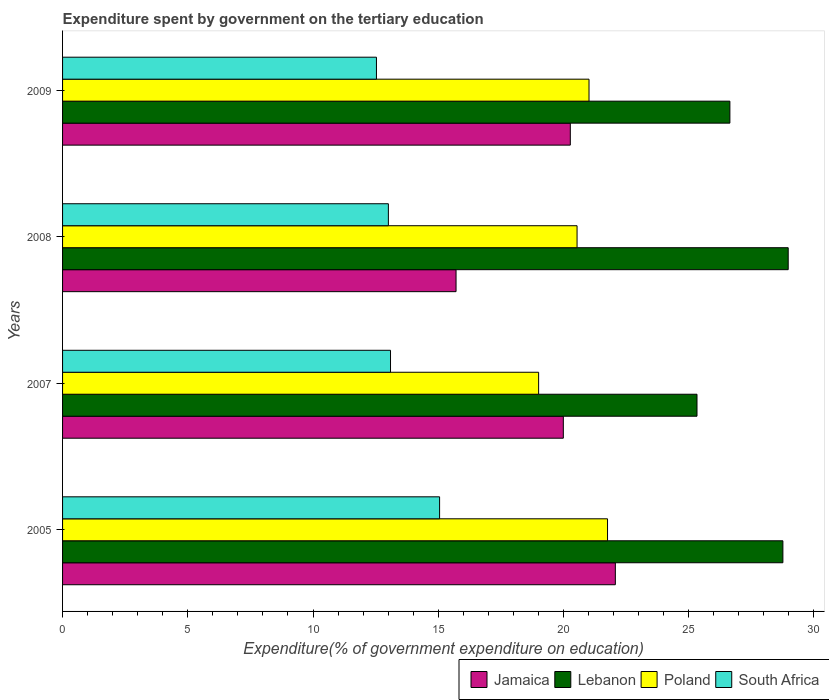Are the number of bars per tick equal to the number of legend labels?
Provide a succinct answer. Yes. Are the number of bars on each tick of the Y-axis equal?
Make the answer very short. Yes. How many bars are there on the 4th tick from the top?
Keep it short and to the point. 4. How many bars are there on the 1st tick from the bottom?
Your response must be concise. 4. In how many cases, is the number of bars for a given year not equal to the number of legend labels?
Your answer should be compact. 0. What is the expenditure spent by government on the tertiary education in Jamaica in 2005?
Provide a short and direct response. 22.07. Across all years, what is the maximum expenditure spent by government on the tertiary education in Lebanon?
Offer a terse response. 28.98. Across all years, what is the minimum expenditure spent by government on the tertiary education in Jamaica?
Keep it short and to the point. 15.71. In which year was the expenditure spent by government on the tertiary education in Poland minimum?
Your answer should be compact. 2007. What is the total expenditure spent by government on the tertiary education in Poland in the graph?
Offer a terse response. 82.33. What is the difference between the expenditure spent by government on the tertiary education in Lebanon in 2005 and that in 2009?
Make the answer very short. 2.12. What is the difference between the expenditure spent by government on the tertiary education in Lebanon in 2008 and the expenditure spent by government on the tertiary education in Jamaica in 2007?
Give a very brief answer. 8.98. What is the average expenditure spent by government on the tertiary education in Lebanon per year?
Your answer should be very brief. 27.43. In the year 2007, what is the difference between the expenditure spent by government on the tertiary education in Jamaica and expenditure spent by government on the tertiary education in South Africa?
Offer a terse response. 6.9. In how many years, is the expenditure spent by government on the tertiary education in Lebanon greater than 15 %?
Give a very brief answer. 4. What is the ratio of the expenditure spent by government on the tertiary education in South Africa in 2005 to that in 2008?
Provide a succinct answer. 1.16. Is the expenditure spent by government on the tertiary education in Jamaica in 2007 less than that in 2009?
Make the answer very short. Yes. What is the difference between the highest and the second highest expenditure spent by government on the tertiary education in South Africa?
Your answer should be very brief. 1.96. What is the difference between the highest and the lowest expenditure spent by government on the tertiary education in Poland?
Offer a terse response. 2.75. Is it the case that in every year, the sum of the expenditure spent by government on the tertiary education in South Africa and expenditure spent by government on the tertiary education in Jamaica is greater than the sum of expenditure spent by government on the tertiary education in Lebanon and expenditure spent by government on the tertiary education in Poland?
Provide a succinct answer. Yes. What does the 2nd bar from the top in 2008 represents?
Provide a succinct answer. Poland. Are all the bars in the graph horizontal?
Ensure brevity in your answer.  Yes. What is the difference between two consecutive major ticks on the X-axis?
Your answer should be very brief. 5. Does the graph contain any zero values?
Your answer should be very brief. No. Does the graph contain grids?
Your answer should be very brief. No. Where does the legend appear in the graph?
Your answer should be very brief. Bottom right. How many legend labels are there?
Ensure brevity in your answer.  4. What is the title of the graph?
Provide a succinct answer. Expenditure spent by government on the tertiary education. Does "Latin America(all income levels)" appear as one of the legend labels in the graph?
Give a very brief answer. No. What is the label or title of the X-axis?
Ensure brevity in your answer.  Expenditure(% of government expenditure on education). What is the label or title of the Y-axis?
Offer a terse response. Years. What is the Expenditure(% of government expenditure on education) in Jamaica in 2005?
Ensure brevity in your answer.  22.07. What is the Expenditure(% of government expenditure on education) in Lebanon in 2005?
Provide a succinct answer. 28.76. What is the Expenditure(% of government expenditure on education) in Poland in 2005?
Your answer should be very brief. 21.76. What is the Expenditure(% of government expenditure on education) of South Africa in 2005?
Make the answer very short. 15.05. What is the Expenditure(% of government expenditure on education) in Jamaica in 2007?
Ensure brevity in your answer.  20. What is the Expenditure(% of government expenditure on education) in Lebanon in 2007?
Ensure brevity in your answer.  25.33. What is the Expenditure(% of government expenditure on education) in Poland in 2007?
Provide a short and direct response. 19.01. What is the Expenditure(% of government expenditure on education) of South Africa in 2007?
Give a very brief answer. 13.1. What is the Expenditure(% of government expenditure on education) in Jamaica in 2008?
Your response must be concise. 15.71. What is the Expenditure(% of government expenditure on education) of Lebanon in 2008?
Offer a very short reply. 28.98. What is the Expenditure(% of government expenditure on education) of Poland in 2008?
Your response must be concise. 20.54. What is the Expenditure(% of government expenditure on education) in South Africa in 2008?
Offer a very short reply. 13.01. What is the Expenditure(% of government expenditure on education) in Jamaica in 2009?
Offer a terse response. 20.27. What is the Expenditure(% of government expenditure on education) of Lebanon in 2009?
Provide a short and direct response. 26.65. What is the Expenditure(% of government expenditure on education) of Poland in 2009?
Make the answer very short. 21.02. What is the Expenditure(% of government expenditure on education) of South Africa in 2009?
Your answer should be compact. 12.53. Across all years, what is the maximum Expenditure(% of government expenditure on education) of Jamaica?
Give a very brief answer. 22.07. Across all years, what is the maximum Expenditure(% of government expenditure on education) in Lebanon?
Offer a terse response. 28.98. Across all years, what is the maximum Expenditure(% of government expenditure on education) of Poland?
Keep it short and to the point. 21.76. Across all years, what is the maximum Expenditure(% of government expenditure on education) in South Africa?
Provide a succinct answer. 15.05. Across all years, what is the minimum Expenditure(% of government expenditure on education) of Jamaica?
Make the answer very short. 15.71. Across all years, what is the minimum Expenditure(% of government expenditure on education) of Lebanon?
Give a very brief answer. 25.33. Across all years, what is the minimum Expenditure(% of government expenditure on education) of Poland?
Give a very brief answer. 19.01. Across all years, what is the minimum Expenditure(% of government expenditure on education) of South Africa?
Ensure brevity in your answer.  12.53. What is the total Expenditure(% of government expenditure on education) of Jamaica in the graph?
Keep it short and to the point. 78.05. What is the total Expenditure(% of government expenditure on education) in Lebanon in the graph?
Make the answer very short. 109.72. What is the total Expenditure(% of government expenditure on education) in Poland in the graph?
Give a very brief answer. 82.33. What is the total Expenditure(% of government expenditure on education) in South Africa in the graph?
Make the answer very short. 53.69. What is the difference between the Expenditure(% of government expenditure on education) of Jamaica in 2005 and that in 2007?
Your response must be concise. 2.08. What is the difference between the Expenditure(% of government expenditure on education) in Lebanon in 2005 and that in 2007?
Offer a very short reply. 3.43. What is the difference between the Expenditure(% of government expenditure on education) of Poland in 2005 and that in 2007?
Keep it short and to the point. 2.75. What is the difference between the Expenditure(% of government expenditure on education) of South Africa in 2005 and that in 2007?
Keep it short and to the point. 1.96. What is the difference between the Expenditure(% of government expenditure on education) in Jamaica in 2005 and that in 2008?
Your answer should be very brief. 6.36. What is the difference between the Expenditure(% of government expenditure on education) in Lebanon in 2005 and that in 2008?
Your answer should be compact. -0.21. What is the difference between the Expenditure(% of government expenditure on education) in Poland in 2005 and that in 2008?
Provide a short and direct response. 1.22. What is the difference between the Expenditure(% of government expenditure on education) in South Africa in 2005 and that in 2008?
Your answer should be compact. 2.05. What is the difference between the Expenditure(% of government expenditure on education) in Jamaica in 2005 and that in 2009?
Provide a short and direct response. 1.8. What is the difference between the Expenditure(% of government expenditure on education) in Lebanon in 2005 and that in 2009?
Keep it short and to the point. 2.12. What is the difference between the Expenditure(% of government expenditure on education) in Poland in 2005 and that in 2009?
Give a very brief answer. 0.74. What is the difference between the Expenditure(% of government expenditure on education) in South Africa in 2005 and that in 2009?
Your answer should be very brief. 2.52. What is the difference between the Expenditure(% of government expenditure on education) in Jamaica in 2007 and that in 2008?
Provide a succinct answer. 4.28. What is the difference between the Expenditure(% of government expenditure on education) of Lebanon in 2007 and that in 2008?
Ensure brevity in your answer.  -3.64. What is the difference between the Expenditure(% of government expenditure on education) of Poland in 2007 and that in 2008?
Your answer should be compact. -1.54. What is the difference between the Expenditure(% of government expenditure on education) of South Africa in 2007 and that in 2008?
Offer a very short reply. 0.09. What is the difference between the Expenditure(% of government expenditure on education) in Jamaica in 2007 and that in 2009?
Offer a very short reply. -0.28. What is the difference between the Expenditure(% of government expenditure on education) of Lebanon in 2007 and that in 2009?
Provide a short and direct response. -1.31. What is the difference between the Expenditure(% of government expenditure on education) of Poland in 2007 and that in 2009?
Provide a short and direct response. -2.01. What is the difference between the Expenditure(% of government expenditure on education) in South Africa in 2007 and that in 2009?
Your answer should be compact. 0.56. What is the difference between the Expenditure(% of government expenditure on education) in Jamaica in 2008 and that in 2009?
Make the answer very short. -4.56. What is the difference between the Expenditure(% of government expenditure on education) in Lebanon in 2008 and that in 2009?
Your response must be concise. 2.33. What is the difference between the Expenditure(% of government expenditure on education) of Poland in 2008 and that in 2009?
Make the answer very short. -0.48. What is the difference between the Expenditure(% of government expenditure on education) of South Africa in 2008 and that in 2009?
Provide a succinct answer. 0.48. What is the difference between the Expenditure(% of government expenditure on education) in Jamaica in 2005 and the Expenditure(% of government expenditure on education) in Lebanon in 2007?
Provide a succinct answer. -3.26. What is the difference between the Expenditure(% of government expenditure on education) of Jamaica in 2005 and the Expenditure(% of government expenditure on education) of Poland in 2007?
Keep it short and to the point. 3.06. What is the difference between the Expenditure(% of government expenditure on education) of Jamaica in 2005 and the Expenditure(% of government expenditure on education) of South Africa in 2007?
Give a very brief answer. 8.98. What is the difference between the Expenditure(% of government expenditure on education) of Lebanon in 2005 and the Expenditure(% of government expenditure on education) of Poland in 2007?
Offer a terse response. 9.75. What is the difference between the Expenditure(% of government expenditure on education) of Lebanon in 2005 and the Expenditure(% of government expenditure on education) of South Africa in 2007?
Your response must be concise. 15.67. What is the difference between the Expenditure(% of government expenditure on education) of Poland in 2005 and the Expenditure(% of government expenditure on education) of South Africa in 2007?
Provide a short and direct response. 8.67. What is the difference between the Expenditure(% of government expenditure on education) of Jamaica in 2005 and the Expenditure(% of government expenditure on education) of Lebanon in 2008?
Your answer should be very brief. -6.9. What is the difference between the Expenditure(% of government expenditure on education) in Jamaica in 2005 and the Expenditure(% of government expenditure on education) in Poland in 2008?
Offer a terse response. 1.53. What is the difference between the Expenditure(% of government expenditure on education) of Jamaica in 2005 and the Expenditure(% of government expenditure on education) of South Africa in 2008?
Offer a very short reply. 9.06. What is the difference between the Expenditure(% of government expenditure on education) of Lebanon in 2005 and the Expenditure(% of government expenditure on education) of Poland in 2008?
Provide a short and direct response. 8.22. What is the difference between the Expenditure(% of government expenditure on education) in Lebanon in 2005 and the Expenditure(% of government expenditure on education) in South Africa in 2008?
Keep it short and to the point. 15.75. What is the difference between the Expenditure(% of government expenditure on education) in Poland in 2005 and the Expenditure(% of government expenditure on education) in South Africa in 2008?
Give a very brief answer. 8.75. What is the difference between the Expenditure(% of government expenditure on education) in Jamaica in 2005 and the Expenditure(% of government expenditure on education) in Lebanon in 2009?
Give a very brief answer. -4.57. What is the difference between the Expenditure(% of government expenditure on education) of Jamaica in 2005 and the Expenditure(% of government expenditure on education) of Poland in 2009?
Provide a succinct answer. 1.05. What is the difference between the Expenditure(% of government expenditure on education) in Jamaica in 2005 and the Expenditure(% of government expenditure on education) in South Africa in 2009?
Your response must be concise. 9.54. What is the difference between the Expenditure(% of government expenditure on education) of Lebanon in 2005 and the Expenditure(% of government expenditure on education) of Poland in 2009?
Give a very brief answer. 7.74. What is the difference between the Expenditure(% of government expenditure on education) of Lebanon in 2005 and the Expenditure(% of government expenditure on education) of South Africa in 2009?
Your answer should be compact. 16.23. What is the difference between the Expenditure(% of government expenditure on education) of Poland in 2005 and the Expenditure(% of government expenditure on education) of South Africa in 2009?
Give a very brief answer. 9.23. What is the difference between the Expenditure(% of government expenditure on education) of Jamaica in 2007 and the Expenditure(% of government expenditure on education) of Lebanon in 2008?
Provide a short and direct response. -8.98. What is the difference between the Expenditure(% of government expenditure on education) in Jamaica in 2007 and the Expenditure(% of government expenditure on education) in Poland in 2008?
Your answer should be very brief. -0.55. What is the difference between the Expenditure(% of government expenditure on education) in Jamaica in 2007 and the Expenditure(% of government expenditure on education) in South Africa in 2008?
Provide a short and direct response. 6.99. What is the difference between the Expenditure(% of government expenditure on education) in Lebanon in 2007 and the Expenditure(% of government expenditure on education) in Poland in 2008?
Keep it short and to the point. 4.79. What is the difference between the Expenditure(% of government expenditure on education) of Lebanon in 2007 and the Expenditure(% of government expenditure on education) of South Africa in 2008?
Make the answer very short. 12.32. What is the difference between the Expenditure(% of government expenditure on education) in Poland in 2007 and the Expenditure(% of government expenditure on education) in South Africa in 2008?
Offer a very short reply. 6. What is the difference between the Expenditure(% of government expenditure on education) in Jamaica in 2007 and the Expenditure(% of government expenditure on education) in Lebanon in 2009?
Ensure brevity in your answer.  -6.65. What is the difference between the Expenditure(% of government expenditure on education) in Jamaica in 2007 and the Expenditure(% of government expenditure on education) in Poland in 2009?
Offer a very short reply. -1.03. What is the difference between the Expenditure(% of government expenditure on education) in Jamaica in 2007 and the Expenditure(% of government expenditure on education) in South Africa in 2009?
Make the answer very short. 7.46. What is the difference between the Expenditure(% of government expenditure on education) of Lebanon in 2007 and the Expenditure(% of government expenditure on education) of Poland in 2009?
Offer a very short reply. 4.31. What is the difference between the Expenditure(% of government expenditure on education) in Lebanon in 2007 and the Expenditure(% of government expenditure on education) in South Africa in 2009?
Your answer should be very brief. 12.8. What is the difference between the Expenditure(% of government expenditure on education) of Poland in 2007 and the Expenditure(% of government expenditure on education) of South Africa in 2009?
Provide a short and direct response. 6.48. What is the difference between the Expenditure(% of government expenditure on education) in Jamaica in 2008 and the Expenditure(% of government expenditure on education) in Lebanon in 2009?
Your answer should be very brief. -10.93. What is the difference between the Expenditure(% of government expenditure on education) in Jamaica in 2008 and the Expenditure(% of government expenditure on education) in Poland in 2009?
Your answer should be compact. -5.31. What is the difference between the Expenditure(% of government expenditure on education) in Jamaica in 2008 and the Expenditure(% of government expenditure on education) in South Africa in 2009?
Make the answer very short. 3.18. What is the difference between the Expenditure(% of government expenditure on education) in Lebanon in 2008 and the Expenditure(% of government expenditure on education) in Poland in 2009?
Offer a very short reply. 7.95. What is the difference between the Expenditure(% of government expenditure on education) in Lebanon in 2008 and the Expenditure(% of government expenditure on education) in South Africa in 2009?
Make the answer very short. 16.44. What is the difference between the Expenditure(% of government expenditure on education) of Poland in 2008 and the Expenditure(% of government expenditure on education) of South Africa in 2009?
Provide a short and direct response. 8.01. What is the average Expenditure(% of government expenditure on education) in Jamaica per year?
Provide a short and direct response. 19.51. What is the average Expenditure(% of government expenditure on education) of Lebanon per year?
Provide a succinct answer. 27.43. What is the average Expenditure(% of government expenditure on education) of Poland per year?
Ensure brevity in your answer.  20.58. What is the average Expenditure(% of government expenditure on education) of South Africa per year?
Provide a succinct answer. 13.42. In the year 2005, what is the difference between the Expenditure(% of government expenditure on education) of Jamaica and Expenditure(% of government expenditure on education) of Lebanon?
Provide a succinct answer. -6.69. In the year 2005, what is the difference between the Expenditure(% of government expenditure on education) in Jamaica and Expenditure(% of government expenditure on education) in Poland?
Give a very brief answer. 0.31. In the year 2005, what is the difference between the Expenditure(% of government expenditure on education) in Jamaica and Expenditure(% of government expenditure on education) in South Africa?
Your response must be concise. 7.02. In the year 2005, what is the difference between the Expenditure(% of government expenditure on education) of Lebanon and Expenditure(% of government expenditure on education) of Poland?
Ensure brevity in your answer.  7. In the year 2005, what is the difference between the Expenditure(% of government expenditure on education) of Lebanon and Expenditure(% of government expenditure on education) of South Africa?
Keep it short and to the point. 13.71. In the year 2005, what is the difference between the Expenditure(% of government expenditure on education) of Poland and Expenditure(% of government expenditure on education) of South Africa?
Your answer should be compact. 6.71. In the year 2007, what is the difference between the Expenditure(% of government expenditure on education) of Jamaica and Expenditure(% of government expenditure on education) of Lebanon?
Provide a short and direct response. -5.34. In the year 2007, what is the difference between the Expenditure(% of government expenditure on education) of Jamaica and Expenditure(% of government expenditure on education) of Poland?
Offer a terse response. 0.99. In the year 2007, what is the difference between the Expenditure(% of government expenditure on education) of Jamaica and Expenditure(% of government expenditure on education) of South Africa?
Your answer should be compact. 6.9. In the year 2007, what is the difference between the Expenditure(% of government expenditure on education) in Lebanon and Expenditure(% of government expenditure on education) in Poland?
Your answer should be very brief. 6.32. In the year 2007, what is the difference between the Expenditure(% of government expenditure on education) in Lebanon and Expenditure(% of government expenditure on education) in South Africa?
Ensure brevity in your answer.  12.24. In the year 2007, what is the difference between the Expenditure(% of government expenditure on education) in Poland and Expenditure(% of government expenditure on education) in South Africa?
Make the answer very short. 5.91. In the year 2008, what is the difference between the Expenditure(% of government expenditure on education) in Jamaica and Expenditure(% of government expenditure on education) in Lebanon?
Provide a short and direct response. -13.26. In the year 2008, what is the difference between the Expenditure(% of government expenditure on education) of Jamaica and Expenditure(% of government expenditure on education) of Poland?
Offer a very short reply. -4.83. In the year 2008, what is the difference between the Expenditure(% of government expenditure on education) of Jamaica and Expenditure(% of government expenditure on education) of South Africa?
Ensure brevity in your answer.  2.7. In the year 2008, what is the difference between the Expenditure(% of government expenditure on education) of Lebanon and Expenditure(% of government expenditure on education) of Poland?
Provide a short and direct response. 8.43. In the year 2008, what is the difference between the Expenditure(% of government expenditure on education) in Lebanon and Expenditure(% of government expenditure on education) in South Africa?
Your answer should be compact. 15.97. In the year 2008, what is the difference between the Expenditure(% of government expenditure on education) of Poland and Expenditure(% of government expenditure on education) of South Africa?
Offer a very short reply. 7.53. In the year 2009, what is the difference between the Expenditure(% of government expenditure on education) in Jamaica and Expenditure(% of government expenditure on education) in Lebanon?
Your answer should be very brief. -6.37. In the year 2009, what is the difference between the Expenditure(% of government expenditure on education) of Jamaica and Expenditure(% of government expenditure on education) of Poland?
Ensure brevity in your answer.  -0.75. In the year 2009, what is the difference between the Expenditure(% of government expenditure on education) of Jamaica and Expenditure(% of government expenditure on education) of South Africa?
Provide a succinct answer. 7.74. In the year 2009, what is the difference between the Expenditure(% of government expenditure on education) in Lebanon and Expenditure(% of government expenditure on education) in Poland?
Offer a terse response. 5.63. In the year 2009, what is the difference between the Expenditure(% of government expenditure on education) of Lebanon and Expenditure(% of government expenditure on education) of South Africa?
Provide a short and direct response. 14.11. In the year 2009, what is the difference between the Expenditure(% of government expenditure on education) of Poland and Expenditure(% of government expenditure on education) of South Africa?
Give a very brief answer. 8.49. What is the ratio of the Expenditure(% of government expenditure on education) of Jamaica in 2005 to that in 2007?
Offer a very short reply. 1.1. What is the ratio of the Expenditure(% of government expenditure on education) in Lebanon in 2005 to that in 2007?
Offer a terse response. 1.14. What is the ratio of the Expenditure(% of government expenditure on education) in Poland in 2005 to that in 2007?
Your response must be concise. 1.14. What is the ratio of the Expenditure(% of government expenditure on education) in South Africa in 2005 to that in 2007?
Offer a terse response. 1.15. What is the ratio of the Expenditure(% of government expenditure on education) of Jamaica in 2005 to that in 2008?
Provide a succinct answer. 1.4. What is the ratio of the Expenditure(% of government expenditure on education) in Poland in 2005 to that in 2008?
Your answer should be very brief. 1.06. What is the ratio of the Expenditure(% of government expenditure on education) in South Africa in 2005 to that in 2008?
Your answer should be very brief. 1.16. What is the ratio of the Expenditure(% of government expenditure on education) in Jamaica in 2005 to that in 2009?
Offer a very short reply. 1.09. What is the ratio of the Expenditure(% of government expenditure on education) in Lebanon in 2005 to that in 2009?
Provide a succinct answer. 1.08. What is the ratio of the Expenditure(% of government expenditure on education) of Poland in 2005 to that in 2009?
Offer a terse response. 1.04. What is the ratio of the Expenditure(% of government expenditure on education) of South Africa in 2005 to that in 2009?
Provide a short and direct response. 1.2. What is the ratio of the Expenditure(% of government expenditure on education) in Jamaica in 2007 to that in 2008?
Your answer should be very brief. 1.27. What is the ratio of the Expenditure(% of government expenditure on education) of Lebanon in 2007 to that in 2008?
Your answer should be compact. 0.87. What is the ratio of the Expenditure(% of government expenditure on education) of Poland in 2007 to that in 2008?
Offer a very short reply. 0.93. What is the ratio of the Expenditure(% of government expenditure on education) of South Africa in 2007 to that in 2008?
Offer a terse response. 1.01. What is the ratio of the Expenditure(% of government expenditure on education) of Jamaica in 2007 to that in 2009?
Offer a terse response. 0.99. What is the ratio of the Expenditure(% of government expenditure on education) in Lebanon in 2007 to that in 2009?
Provide a short and direct response. 0.95. What is the ratio of the Expenditure(% of government expenditure on education) of Poland in 2007 to that in 2009?
Your answer should be very brief. 0.9. What is the ratio of the Expenditure(% of government expenditure on education) in South Africa in 2007 to that in 2009?
Give a very brief answer. 1.04. What is the ratio of the Expenditure(% of government expenditure on education) of Jamaica in 2008 to that in 2009?
Offer a terse response. 0.78. What is the ratio of the Expenditure(% of government expenditure on education) of Lebanon in 2008 to that in 2009?
Give a very brief answer. 1.09. What is the ratio of the Expenditure(% of government expenditure on education) of Poland in 2008 to that in 2009?
Provide a succinct answer. 0.98. What is the ratio of the Expenditure(% of government expenditure on education) of South Africa in 2008 to that in 2009?
Ensure brevity in your answer.  1.04. What is the difference between the highest and the second highest Expenditure(% of government expenditure on education) in Jamaica?
Your response must be concise. 1.8. What is the difference between the highest and the second highest Expenditure(% of government expenditure on education) in Lebanon?
Your answer should be very brief. 0.21. What is the difference between the highest and the second highest Expenditure(% of government expenditure on education) in Poland?
Provide a short and direct response. 0.74. What is the difference between the highest and the second highest Expenditure(% of government expenditure on education) in South Africa?
Provide a short and direct response. 1.96. What is the difference between the highest and the lowest Expenditure(% of government expenditure on education) of Jamaica?
Your response must be concise. 6.36. What is the difference between the highest and the lowest Expenditure(% of government expenditure on education) in Lebanon?
Make the answer very short. 3.64. What is the difference between the highest and the lowest Expenditure(% of government expenditure on education) of Poland?
Provide a short and direct response. 2.75. What is the difference between the highest and the lowest Expenditure(% of government expenditure on education) in South Africa?
Offer a very short reply. 2.52. 